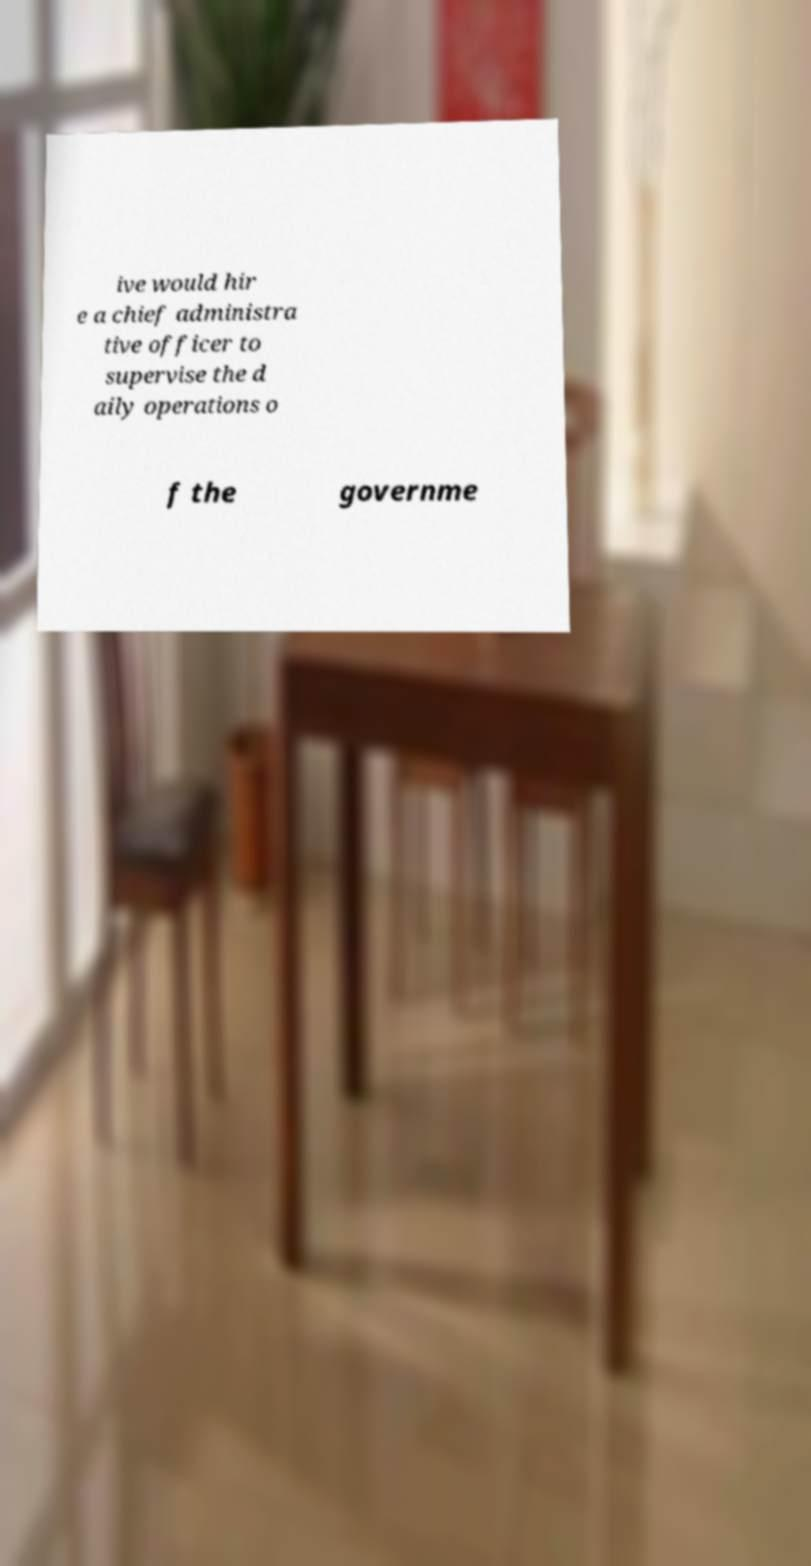What messages or text are displayed in this image? I need them in a readable, typed format. ive would hir e a chief administra tive officer to supervise the d aily operations o f the governme 